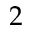<formula> <loc_0><loc_0><loc_500><loc_500>2</formula> 